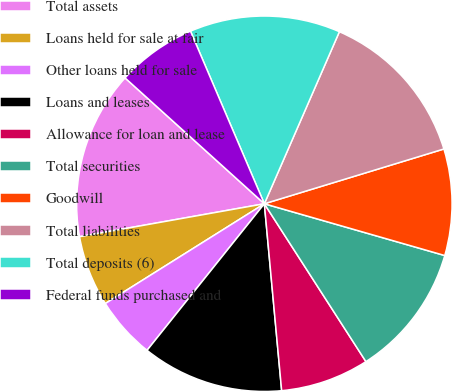<chart> <loc_0><loc_0><loc_500><loc_500><pie_chart><fcel>Total assets<fcel>Loans held for sale at fair<fcel>Other loans held for sale<fcel>Loans and leases<fcel>Allowance for loan and lease<fcel>Total securities<fcel>Goodwill<fcel>Total liabilities<fcel>Total deposits (6)<fcel>Federal funds purchased and<nl><fcel>14.5%<fcel>6.11%<fcel>5.34%<fcel>12.21%<fcel>7.63%<fcel>11.45%<fcel>9.16%<fcel>13.74%<fcel>12.98%<fcel>6.87%<nl></chart> 